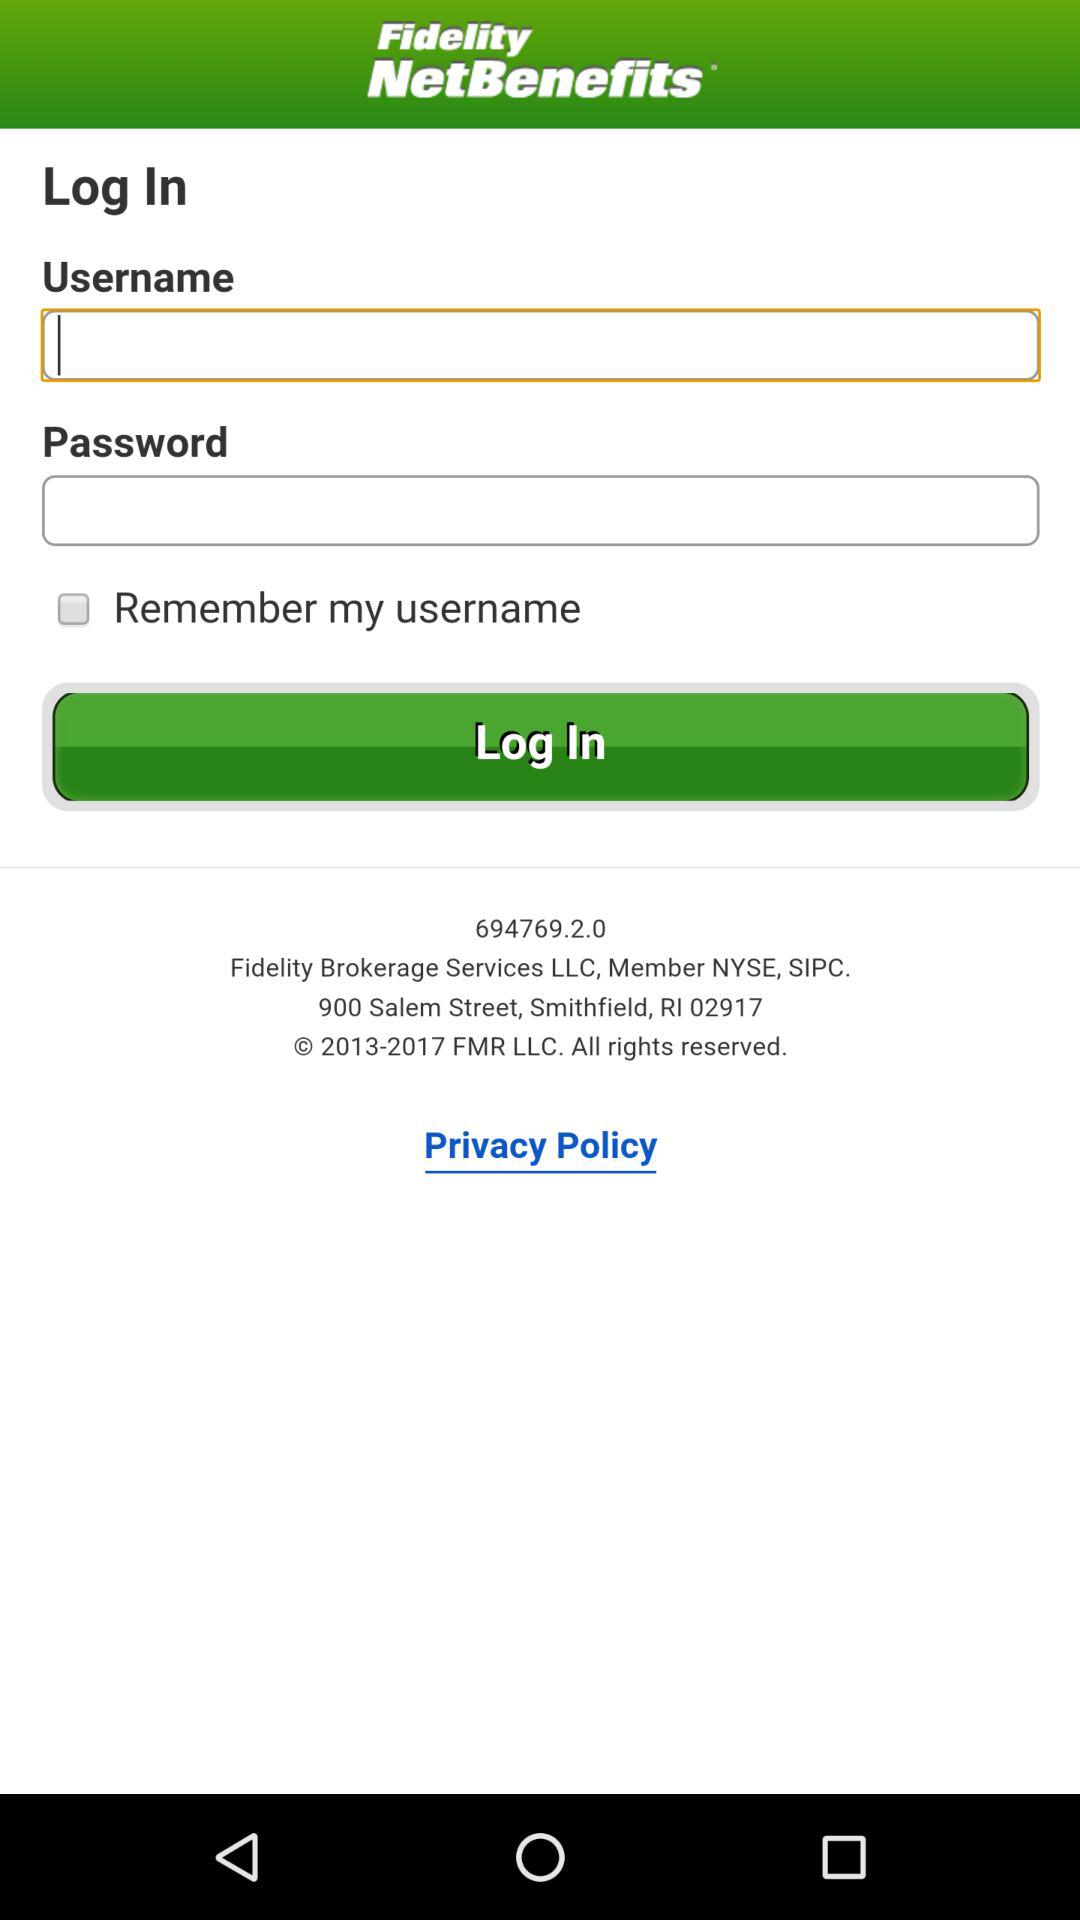What is the status of the "Remember my username"? The status of the "Remember my username" is "off". 